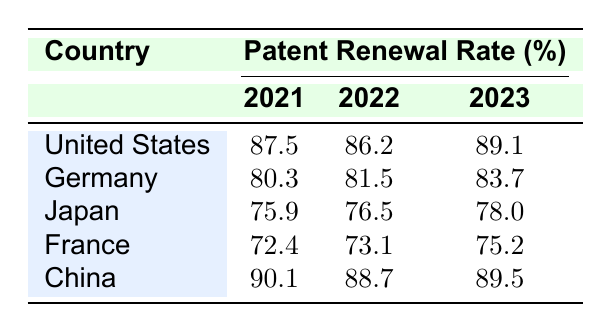What was the patent renewal rate for the United States in 2022? The table shows that the renewal rate for the United States in 2022 is 86.2%.
Answer: 86.2 Which country had the highest patent renewal rate in 2021? According to the table, China had the highest renewal rate in 2021 with 90.1%.
Answer: China What is the average patent renewal rate for Germany from 2021 to 2023? The rates for Germany are 80.3, 81.5, and 83.7. The average is (80.3 + 81.5 + 83.7) / 3 = 81.5.
Answer: 81.5 Did the patent renewal rate for Japan increase from 2021 to 2023? The rates for Japan are 75.9 in 2021 and 78.0 in 2023, indicating an increase.
Answer: Yes What is the change in patent renewal rate for France from 2021 to 2023? France had renewal rates of 72.4 in 2021 and 75.2 in 2023. The change is 75.2 - 72.4 = 2.8.
Answer: 2.8 Which country had the lowest average renewal rate over the three years? The average rates are United States (87.6), Germany (81.8), Japan (76.8), France (73.6), and China (89.4). France has the lowest average at 73.6.
Answer: France What was the average cost for patent renewals in Germany across the three years? The costs for Germany are 600, 620, and 640. The average cost is (600 + 620 + 640) / 3 = 620.
Answer: 620 Which country saw an increase in renewal rates every year from 2021 to 2023? By looking at the table, only the United States and China consistently increased their renewal rates each year.
Answer: United States and China What is the difference in the average renewal rate between China and Japan for 2023? The renewal rate for China in 2023 was 89.5, and Japan's was 78.0. The difference is 89.5 - 78.0 = 11.5.
Answer: 11.5 Is the renewal rate for French patents in 2022 higher than that of German patents in 2021? The renewal rate in France for 2022 is 73.1, while Germany had 80.3 in 2021, so it is lower.
Answer: No 